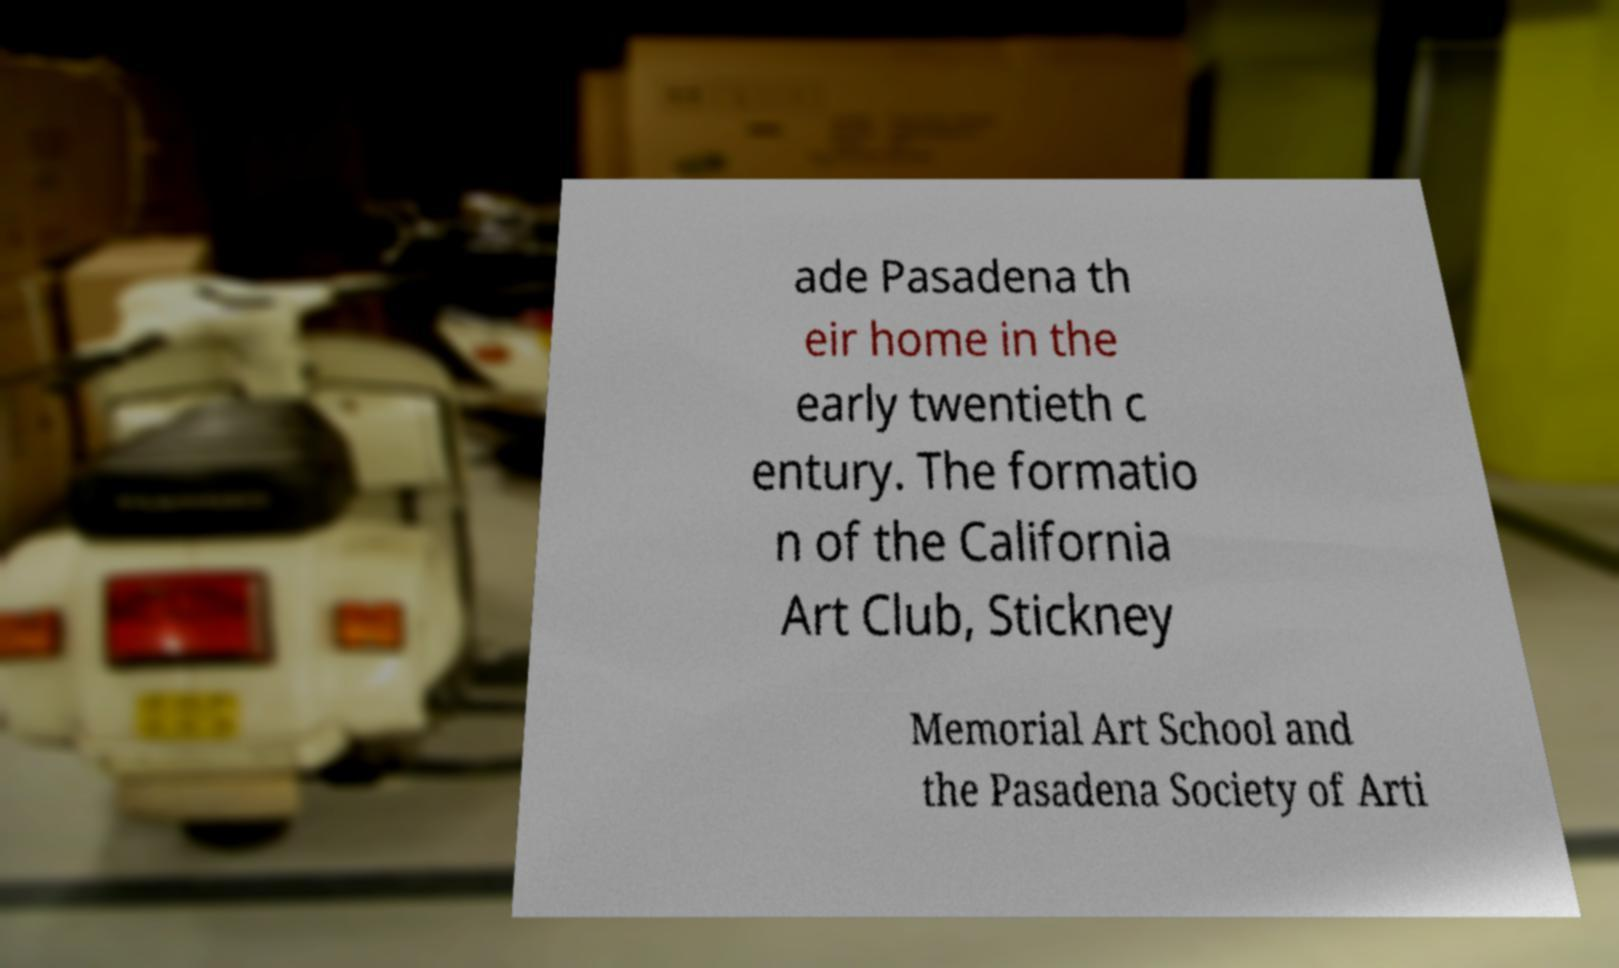I need the written content from this picture converted into text. Can you do that? ade Pasadena th eir home in the early twentieth c entury. The formatio n of the California Art Club, Stickney Memorial Art School and the Pasadena Society of Arti 